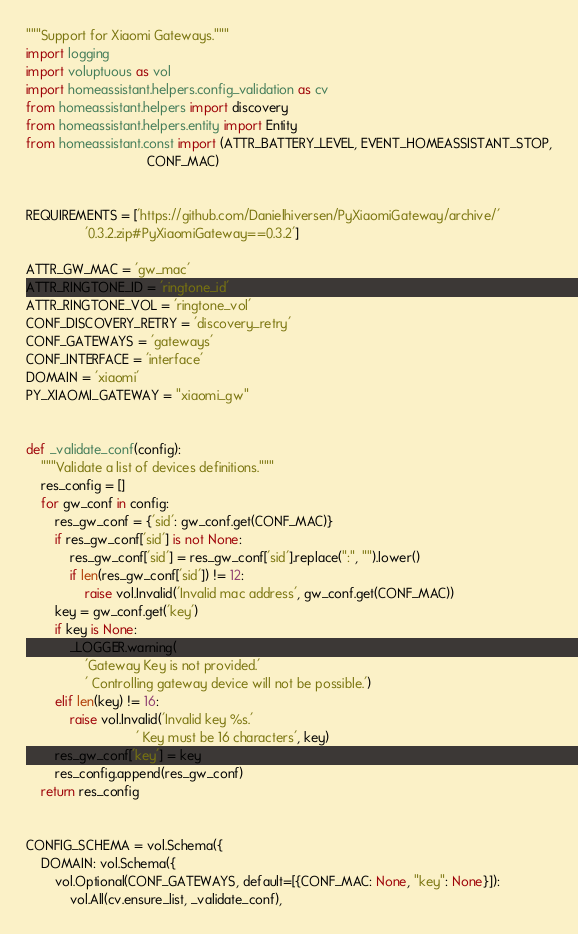<code> <loc_0><loc_0><loc_500><loc_500><_Python_>"""Support for Xiaomi Gateways."""
import logging
import voluptuous as vol
import homeassistant.helpers.config_validation as cv
from homeassistant.helpers import discovery
from homeassistant.helpers.entity import Entity
from homeassistant.const import (ATTR_BATTERY_LEVEL, EVENT_HOMEASSISTANT_STOP,
                                 CONF_MAC)


REQUIREMENTS = ['https://github.com/Danielhiversen/PyXiaomiGateway/archive/'
                '0.3.2.zip#PyXiaomiGateway==0.3.2']

ATTR_GW_MAC = 'gw_mac'
ATTR_RINGTONE_ID = 'ringtone_id'
ATTR_RINGTONE_VOL = 'ringtone_vol'
CONF_DISCOVERY_RETRY = 'discovery_retry'
CONF_GATEWAYS = 'gateways'
CONF_INTERFACE = 'interface'
DOMAIN = 'xiaomi'
PY_XIAOMI_GATEWAY = "xiaomi_gw"


def _validate_conf(config):
    """Validate a list of devices definitions."""
    res_config = []
    for gw_conf in config:
        res_gw_conf = {'sid': gw_conf.get(CONF_MAC)}
        if res_gw_conf['sid'] is not None:
            res_gw_conf['sid'] = res_gw_conf['sid'].replace(":", "").lower()
            if len(res_gw_conf['sid']) != 12:
                raise vol.Invalid('Invalid mac address', gw_conf.get(CONF_MAC))
        key = gw_conf.get('key')
        if key is None:
            _LOGGER.warning(
                'Gateway Key is not provided.'
                ' Controlling gateway device will not be possible.')
        elif len(key) != 16:
            raise vol.Invalid('Invalid key %s.'
                              ' Key must be 16 characters', key)
        res_gw_conf['key'] = key
        res_config.append(res_gw_conf)
    return res_config


CONFIG_SCHEMA = vol.Schema({
    DOMAIN: vol.Schema({
        vol.Optional(CONF_GATEWAYS, default=[{CONF_MAC: None, "key": None}]):
            vol.All(cv.ensure_list, _validate_conf),</code> 